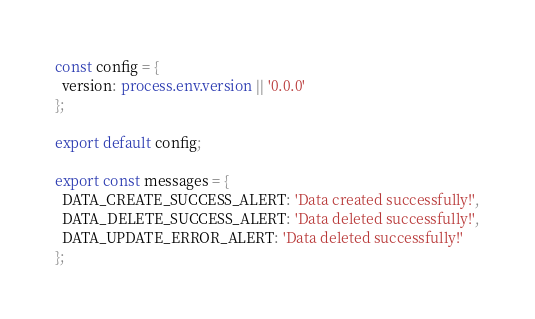<code> <loc_0><loc_0><loc_500><loc_500><_TypeScript_>const config = {
  version: process.env.version || '0.0.0'
};

export default config;

export const messages = {
  DATA_CREATE_SUCCESS_ALERT: 'Data created successfully!',
  DATA_DELETE_SUCCESS_ALERT: 'Data deleted successfully!',
  DATA_UPDATE_ERROR_ALERT: 'Data deleted successfully!'
};
</code> 